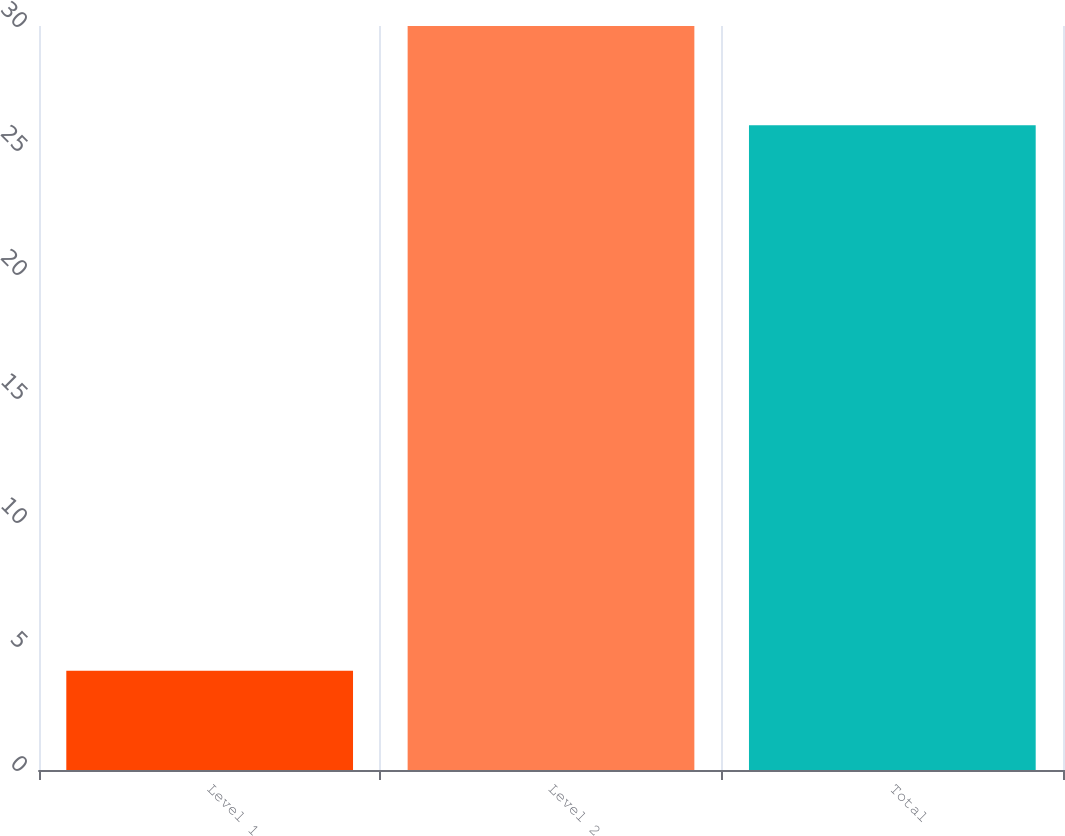Convert chart to OTSL. <chart><loc_0><loc_0><loc_500><loc_500><bar_chart><fcel>Level 1<fcel>Level 2<fcel>Total<nl><fcel>4<fcel>30<fcel>26<nl></chart> 